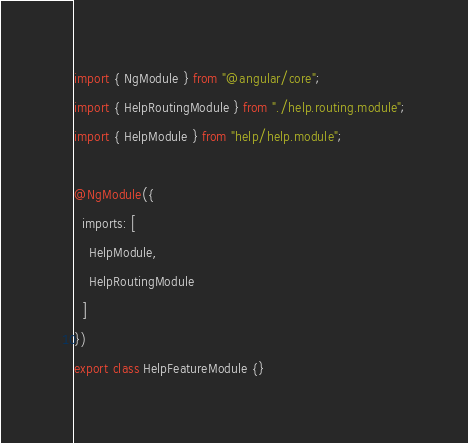<code> <loc_0><loc_0><loc_500><loc_500><_TypeScript_>import { NgModule } from "@angular/core";
import { HelpRoutingModule } from "./help.routing.module";
import { HelpModule } from "help/help.module";

@NgModule({
  imports: [
    HelpModule,
    HelpRoutingModule
  ]
})
export class HelpFeatureModule {}
</code> 